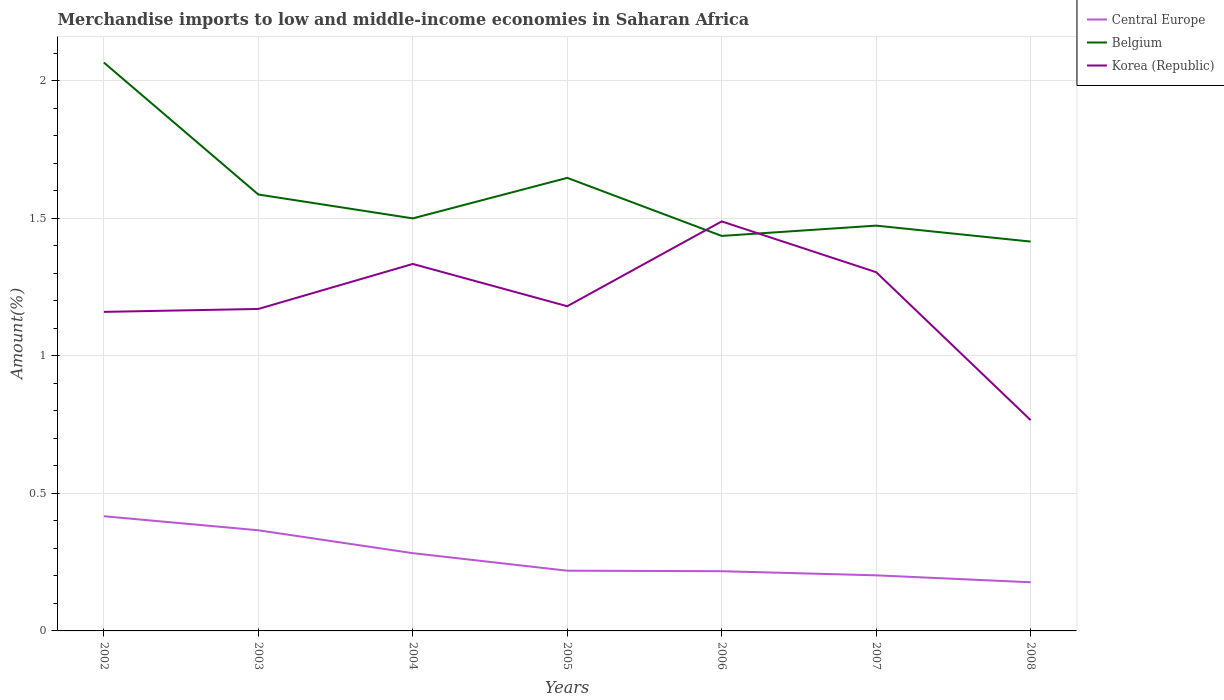How many different coloured lines are there?
Make the answer very short. 3. Does the line corresponding to Central Europe intersect with the line corresponding to Korea (Republic)?
Provide a succinct answer. No. Is the number of lines equal to the number of legend labels?
Give a very brief answer. Yes. Across all years, what is the maximum percentage of amount earned from merchandise imports in Central Europe?
Provide a succinct answer. 0.18. What is the total percentage of amount earned from merchandise imports in Korea (Republic) in the graph?
Provide a succinct answer. -0.17. What is the difference between the highest and the second highest percentage of amount earned from merchandise imports in Belgium?
Provide a short and direct response. 0.65. What is the difference between the highest and the lowest percentage of amount earned from merchandise imports in Central Europe?
Offer a very short reply. 3. Is the percentage of amount earned from merchandise imports in Central Europe strictly greater than the percentage of amount earned from merchandise imports in Belgium over the years?
Your response must be concise. Yes. How many years are there in the graph?
Offer a terse response. 7. What is the difference between two consecutive major ticks on the Y-axis?
Keep it short and to the point. 0.5. Where does the legend appear in the graph?
Provide a succinct answer. Top right. How many legend labels are there?
Your response must be concise. 3. How are the legend labels stacked?
Your response must be concise. Vertical. What is the title of the graph?
Your response must be concise. Merchandise imports to low and middle-income economies in Saharan Africa. Does "Middle income" appear as one of the legend labels in the graph?
Keep it short and to the point. No. What is the label or title of the X-axis?
Your answer should be compact. Years. What is the label or title of the Y-axis?
Give a very brief answer. Amount(%). What is the Amount(%) of Central Europe in 2002?
Your answer should be very brief. 0.42. What is the Amount(%) of Belgium in 2002?
Make the answer very short. 2.07. What is the Amount(%) in Korea (Republic) in 2002?
Offer a very short reply. 1.16. What is the Amount(%) of Central Europe in 2003?
Your answer should be compact. 0.37. What is the Amount(%) of Belgium in 2003?
Offer a terse response. 1.59. What is the Amount(%) of Korea (Republic) in 2003?
Provide a succinct answer. 1.17. What is the Amount(%) in Central Europe in 2004?
Offer a terse response. 0.28. What is the Amount(%) in Belgium in 2004?
Keep it short and to the point. 1.5. What is the Amount(%) in Korea (Republic) in 2004?
Your response must be concise. 1.33. What is the Amount(%) in Central Europe in 2005?
Your answer should be compact. 0.22. What is the Amount(%) of Belgium in 2005?
Provide a succinct answer. 1.65. What is the Amount(%) of Korea (Republic) in 2005?
Offer a very short reply. 1.18. What is the Amount(%) of Central Europe in 2006?
Offer a terse response. 0.22. What is the Amount(%) of Belgium in 2006?
Give a very brief answer. 1.44. What is the Amount(%) in Korea (Republic) in 2006?
Your response must be concise. 1.49. What is the Amount(%) in Central Europe in 2007?
Make the answer very short. 0.2. What is the Amount(%) of Belgium in 2007?
Offer a very short reply. 1.47. What is the Amount(%) of Korea (Republic) in 2007?
Give a very brief answer. 1.3. What is the Amount(%) of Central Europe in 2008?
Provide a short and direct response. 0.18. What is the Amount(%) in Belgium in 2008?
Your answer should be compact. 1.42. What is the Amount(%) in Korea (Republic) in 2008?
Offer a very short reply. 0.77. Across all years, what is the maximum Amount(%) in Central Europe?
Offer a very short reply. 0.42. Across all years, what is the maximum Amount(%) in Belgium?
Ensure brevity in your answer.  2.07. Across all years, what is the maximum Amount(%) in Korea (Republic)?
Give a very brief answer. 1.49. Across all years, what is the minimum Amount(%) of Central Europe?
Provide a short and direct response. 0.18. Across all years, what is the minimum Amount(%) of Belgium?
Your answer should be compact. 1.42. Across all years, what is the minimum Amount(%) of Korea (Republic)?
Your response must be concise. 0.77. What is the total Amount(%) in Central Europe in the graph?
Your answer should be compact. 1.88. What is the total Amount(%) of Belgium in the graph?
Your answer should be very brief. 11.13. What is the total Amount(%) in Korea (Republic) in the graph?
Offer a very short reply. 8.41. What is the difference between the Amount(%) of Central Europe in 2002 and that in 2003?
Offer a terse response. 0.05. What is the difference between the Amount(%) of Belgium in 2002 and that in 2003?
Provide a short and direct response. 0.48. What is the difference between the Amount(%) of Korea (Republic) in 2002 and that in 2003?
Provide a short and direct response. -0.01. What is the difference between the Amount(%) of Central Europe in 2002 and that in 2004?
Make the answer very short. 0.13. What is the difference between the Amount(%) of Belgium in 2002 and that in 2004?
Keep it short and to the point. 0.57. What is the difference between the Amount(%) in Korea (Republic) in 2002 and that in 2004?
Your answer should be very brief. -0.17. What is the difference between the Amount(%) of Central Europe in 2002 and that in 2005?
Ensure brevity in your answer.  0.2. What is the difference between the Amount(%) of Belgium in 2002 and that in 2005?
Your response must be concise. 0.42. What is the difference between the Amount(%) of Korea (Republic) in 2002 and that in 2005?
Keep it short and to the point. -0.02. What is the difference between the Amount(%) in Central Europe in 2002 and that in 2006?
Offer a very short reply. 0.2. What is the difference between the Amount(%) of Belgium in 2002 and that in 2006?
Your response must be concise. 0.63. What is the difference between the Amount(%) in Korea (Republic) in 2002 and that in 2006?
Your response must be concise. -0.33. What is the difference between the Amount(%) of Central Europe in 2002 and that in 2007?
Make the answer very short. 0.21. What is the difference between the Amount(%) of Belgium in 2002 and that in 2007?
Your answer should be compact. 0.59. What is the difference between the Amount(%) in Korea (Republic) in 2002 and that in 2007?
Give a very brief answer. -0.14. What is the difference between the Amount(%) in Central Europe in 2002 and that in 2008?
Offer a very short reply. 0.24. What is the difference between the Amount(%) in Belgium in 2002 and that in 2008?
Make the answer very short. 0.65. What is the difference between the Amount(%) in Korea (Republic) in 2002 and that in 2008?
Give a very brief answer. 0.39. What is the difference between the Amount(%) of Central Europe in 2003 and that in 2004?
Provide a short and direct response. 0.08. What is the difference between the Amount(%) of Belgium in 2003 and that in 2004?
Ensure brevity in your answer.  0.09. What is the difference between the Amount(%) in Korea (Republic) in 2003 and that in 2004?
Keep it short and to the point. -0.16. What is the difference between the Amount(%) of Central Europe in 2003 and that in 2005?
Give a very brief answer. 0.15. What is the difference between the Amount(%) of Belgium in 2003 and that in 2005?
Offer a very short reply. -0.06. What is the difference between the Amount(%) in Korea (Republic) in 2003 and that in 2005?
Provide a succinct answer. -0.01. What is the difference between the Amount(%) of Central Europe in 2003 and that in 2006?
Provide a short and direct response. 0.15. What is the difference between the Amount(%) of Belgium in 2003 and that in 2006?
Provide a succinct answer. 0.15. What is the difference between the Amount(%) of Korea (Republic) in 2003 and that in 2006?
Make the answer very short. -0.32. What is the difference between the Amount(%) of Central Europe in 2003 and that in 2007?
Provide a short and direct response. 0.16. What is the difference between the Amount(%) in Belgium in 2003 and that in 2007?
Your answer should be compact. 0.11. What is the difference between the Amount(%) of Korea (Republic) in 2003 and that in 2007?
Your response must be concise. -0.13. What is the difference between the Amount(%) in Central Europe in 2003 and that in 2008?
Your response must be concise. 0.19. What is the difference between the Amount(%) of Belgium in 2003 and that in 2008?
Provide a succinct answer. 0.17. What is the difference between the Amount(%) in Korea (Republic) in 2003 and that in 2008?
Your answer should be compact. 0.4. What is the difference between the Amount(%) in Central Europe in 2004 and that in 2005?
Give a very brief answer. 0.06. What is the difference between the Amount(%) in Belgium in 2004 and that in 2005?
Offer a terse response. -0.15. What is the difference between the Amount(%) of Korea (Republic) in 2004 and that in 2005?
Make the answer very short. 0.15. What is the difference between the Amount(%) of Central Europe in 2004 and that in 2006?
Your answer should be compact. 0.07. What is the difference between the Amount(%) in Belgium in 2004 and that in 2006?
Keep it short and to the point. 0.06. What is the difference between the Amount(%) in Korea (Republic) in 2004 and that in 2006?
Your answer should be very brief. -0.15. What is the difference between the Amount(%) in Central Europe in 2004 and that in 2007?
Make the answer very short. 0.08. What is the difference between the Amount(%) in Belgium in 2004 and that in 2007?
Your answer should be compact. 0.03. What is the difference between the Amount(%) in Korea (Republic) in 2004 and that in 2007?
Your answer should be very brief. 0.03. What is the difference between the Amount(%) of Central Europe in 2004 and that in 2008?
Give a very brief answer. 0.11. What is the difference between the Amount(%) of Belgium in 2004 and that in 2008?
Ensure brevity in your answer.  0.08. What is the difference between the Amount(%) in Korea (Republic) in 2004 and that in 2008?
Give a very brief answer. 0.57. What is the difference between the Amount(%) of Central Europe in 2005 and that in 2006?
Make the answer very short. 0. What is the difference between the Amount(%) of Belgium in 2005 and that in 2006?
Make the answer very short. 0.21. What is the difference between the Amount(%) of Korea (Republic) in 2005 and that in 2006?
Provide a succinct answer. -0.31. What is the difference between the Amount(%) in Central Europe in 2005 and that in 2007?
Give a very brief answer. 0.02. What is the difference between the Amount(%) in Belgium in 2005 and that in 2007?
Make the answer very short. 0.17. What is the difference between the Amount(%) of Korea (Republic) in 2005 and that in 2007?
Offer a terse response. -0.12. What is the difference between the Amount(%) in Central Europe in 2005 and that in 2008?
Your response must be concise. 0.04. What is the difference between the Amount(%) of Belgium in 2005 and that in 2008?
Make the answer very short. 0.23. What is the difference between the Amount(%) in Korea (Republic) in 2005 and that in 2008?
Ensure brevity in your answer.  0.41. What is the difference between the Amount(%) in Central Europe in 2006 and that in 2007?
Offer a terse response. 0.01. What is the difference between the Amount(%) in Belgium in 2006 and that in 2007?
Ensure brevity in your answer.  -0.04. What is the difference between the Amount(%) of Korea (Republic) in 2006 and that in 2007?
Keep it short and to the point. 0.18. What is the difference between the Amount(%) of Central Europe in 2006 and that in 2008?
Offer a terse response. 0.04. What is the difference between the Amount(%) of Belgium in 2006 and that in 2008?
Provide a short and direct response. 0.02. What is the difference between the Amount(%) in Korea (Republic) in 2006 and that in 2008?
Offer a terse response. 0.72. What is the difference between the Amount(%) in Central Europe in 2007 and that in 2008?
Your answer should be compact. 0.03. What is the difference between the Amount(%) in Belgium in 2007 and that in 2008?
Give a very brief answer. 0.06. What is the difference between the Amount(%) in Korea (Republic) in 2007 and that in 2008?
Provide a short and direct response. 0.54. What is the difference between the Amount(%) of Central Europe in 2002 and the Amount(%) of Belgium in 2003?
Offer a very short reply. -1.17. What is the difference between the Amount(%) of Central Europe in 2002 and the Amount(%) of Korea (Republic) in 2003?
Your answer should be very brief. -0.75. What is the difference between the Amount(%) in Belgium in 2002 and the Amount(%) in Korea (Republic) in 2003?
Provide a short and direct response. 0.9. What is the difference between the Amount(%) of Central Europe in 2002 and the Amount(%) of Belgium in 2004?
Offer a very short reply. -1.08. What is the difference between the Amount(%) in Central Europe in 2002 and the Amount(%) in Korea (Republic) in 2004?
Your answer should be very brief. -0.92. What is the difference between the Amount(%) in Belgium in 2002 and the Amount(%) in Korea (Republic) in 2004?
Provide a succinct answer. 0.73. What is the difference between the Amount(%) in Central Europe in 2002 and the Amount(%) in Belgium in 2005?
Keep it short and to the point. -1.23. What is the difference between the Amount(%) in Central Europe in 2002 and the Amount(%) in Korea (Republic) in 2005?
Ensure brevity in your answer.  -0.76. What is the difference between the Amount(%) in Belgium in 2002 and the Amount(%) in Korea (Republic) in 2005?
Offer a very short reply. 0.89. What is the difference between the Amount(%) in Central Europe in 2002 and the Amount(%) in Belgium in 2006?
Ensure brevity in your answer.  -1.02. What is the difference between the Amount(%) in Central Europe in 2002 and the Amount(%) in Korea (Republic) in 2006?
Provide a succinct answer. -1.07. What is the difference between the Amount(%) in Belgium in 2002 and the Amount(%) in Korea (Republic) in 2006?
Your answer should be compact. 0.58. What is the difference between the Amount(%) of Central Europe in 2002 and the Amount(%) of Belgium in 2007?
Your answer should be very brief. -1.06. What is the difference between the Amount(%) in Central Europe in 2002 and the Amount(%) in Korea (Republic) in 2007?
Give a very brief answer. -0.89. What is the difference between the Amount(%) in Belgium in 2002 and the Amount(%) in Korea (Republic) in 2007?
Give a very brief answer. 0.76. What is the difference between the Amount(%) of Central Europe in 2002 and the Amount(%) of Belgium in 2008?
Give a very brief answer. -1. What is the difference between the Amount(%) of Central Europe in 2002 and the Amount(%) of Korea (Republic) in 2008?
Ensure brevity in your answer.  -0.35. What is the difference between the Amount(%) in Belgium in 2002 and the Amount(%) in Korea (Republic) in 2008?
Your answer should be very brief. 1.3. What is the difference between the Amount(%) of Central Europe in 2003 and the Amount(%) of Belgium in 2004?
Provide a short and direct response. -1.13. What is the difference between the Amount(%) of Central Europe in 2003 and the Amount(%) of Korea (Republic) in 2004?
Provide a succinct answer. -0.97. What is the difference between the Amount(%) in Belgium in 2003 and the Amount(%) in Korea (Republic) in 2004?
Keep it short and to the point. 0.25. What is the difference between the Amount(%) of Central Europe in 2003 and the Amount(%) of Belgium in 2005?
Make the answer very short. -1.28. What is the difference between the Amount(%) in Central Europe in 2003 and the Amount(%) in Korea (Republic) in 2005?
Offer a very short reply. -0.81. What is the difference between the Amount(%) of Belgium in 2003 and the Amount(%) of Korea (Republic) in 2005?
Provide a short and direct response. 0.41. What is the difference between the Amount(%) in Central Europe in 2003 and the Amount(%) in Belgium in 2006?
Offer a very short reply. -1.07. What is the difference between the Amount(%) of Central Europe in 2003 and the Amount(%) of Korea (Republic) in 2006?
Offer a very short reply. -1.12. What is the difference between the Amount(%) in Belgium in 2003 and the Amount(%) in Korea (Republic) in 2006?
Keep it short and to the point. 0.1. What is the difference between the Amount(%) of Central Europe in 2003 and the Amount(%) of Belgium in 2007?
Offer a very short reply. -1.11. What is the difference between the Amount(%) in Central Europe in 2003 and the Amount(%) in Korea (Republic) in 2007?
Your answer should be very brief. -0.94. What is the difference between the Amount(%) in Belgium in 2003 and the Amount(%) in Korea (Republic) in 2007?
Your answer should be compact. 0.28. What is the difference between the Amount(%) of Central Europe in 2003 and the Amount(%) of Belgium in 2008?
Your response must be concise. -1.05. What is the difference between the Amount(%) in Central Europe in 2003 and the Amount(%) in Korea (Republic) in 2008?
Ensure brevity in your answer.  -0.4. What is the difference between the Amount(%) of Belgium in 2003 and the Amount(%) of Korea (Republic) in 2008?
Provide a succinct answer. 0.82. What is the difference between the Amount(%) of Central Europe in 2004 and the Amount(%) of Belgium in 2005?
Your answer should be very brief. -1.36. What is the difference between the Amount(%) in Central Europe in 2004 and the Amount(%) in Korea (Republic) in 2005?
Offer a very short reply. -0.9. What is the difference between the Amount(%) in Belgium in 2004 and the Amount(%) in Korea (Republic) in 2005?
Make the answer very short. 0.32. What is the difference between the Amount(%) in Central Europe in 2004 and the Amount(%) in Belgium in 2006?
Ensure brevity in your answer.  -1.15. What is the difference between the Amount(%) in Central Europe in 2004 and the Amount(%) in Korea (Republic) in 2006?
Offer a terse response. -1.21. What is the difference between the Amount(%) of Belgium in 2004 and the Amount(%) of Korea (Republic) in 2006?
Provide a succinct answer. 0.01. What is the difference between the Amount(%) of Central Europe in 2004 and the Amount(%) of Belgium in 2007?
Ensure brevity in your answer.  -1.19. What is the difference between the Amount(%) in Central Europe in 2004 and the Amount(%) in Korea (Republic) in 2007?
Your response must be concise. -1.02. What is the difference between the Amount(%) in Belgium in 2004 and the Amount(%) in Korea (Republic) in 2007?
Provide a succinct answer. 0.2. What is the difference between the Amount(%) in Central Europe in 2004 and the Amount(%) in Belgium in 2008?
Your answer should be very brief. -1.13. What is the difference between the Amount(%) of Central Europe in 2004 and the Amount(%) of Korea (Republic) in 2008?
Make the answer very short. -0.48. What is the difference between the Amount(%) of Belgium in 2004 and the Amount(%) of Korea (Republic) in 2008?
Provide a succinct answer. 0.73. What is the difference between the Amount(%) in Central Europe in 2005 and the Amount(%) in Belgium in 2006?
Offer a very short reply. -1.22. What is the difference between the Amount(%) of Central Europe in 2005 and the Amount(%) of Korea (Republic) in 2006?
Your response must be concise. -1.27. What is the difference between the Amount(%) of Belgium in 2005 and the Amount(%) of Korea (Republic) in 2006?
Ensure brevity in your answer.  0.16. What is the difference between the Amount(%) in Central Europe in 2005 and the Amount(%) in Belgium in 2007?
Ensure brevity in your answer.  -1.25. What is the difference between the Amount(%) of Central Europe in 2005 and the Amount(%) of Korea (Republic) in 2007?
Make the answer very short. -1.09. What is the difference between the Amount(%) in Belgium in 2005 and the Amount(%) in Korea (Republic) in 2007?
Provide a short and direct response. 0.34. What is the difference between the Amount(%) of Central Europe in 2005 and the Amount(%) of Belgium in 2008?
Your answer should be compact. -1.2. What is the difference between the Amount(%) of Central Europe in 2005 and the Amount(%) of Korea (Republic) in 2008?
Ensure brevity in your answer.  -0.55. What is the difference between the Amount(%) of Belgium in 2005 and the Amount(%) of Korea (Republic) in 2008?
Your answer should be very brief. 0.88. What is the difference between the Amount(%) in Central Europe in 2006 and the Amount(%) in Belgium in 2007?
Your response must be concise. -1.26. What is the difference between the Amount(%) of Central Europe in 2006 and the Amount(%) of Korea (Republic) in 2007?
Ensure brevity in your answer.  -1.09. What is the difference between the Amount(%) of Belgium in 2006 and the Amount(%) of Korea (Republic) in 2007?
Your response must be concise. 0.13. What is the difference between the Amount(%) in Central Europe in 2006 and the Amount(%) in Belgium in 2008?
Provide a succinct answer. -1.2. What is the difference between the Amount(%) of Central Europe in 2006 and the Amount(%) of Korea (Republic) in 2008?
Provide a short and direct response. -0.55. What is the difference between the Amount(%) in Belgium in 2006 and the Amount(%) in Korea (Republic) in 2008?
Offer a very short reply. 0.67. What is the difference between the Amount(%) of Central Europe in 2007 and the Amount(%) of Belgium in 2008?
Keep it short and to the point. -1.21. What is the difference between the Amount(%) of Central Europe in 2007 and the Amount(%) of Korea (Republic) in 2008?
Your answer should be compact. -0.56. What is the difference between the Amount(%) in Belgium in 2007 and the Amount(%) in Korea (Republic) in 2008?
Provide a short and direct response. 0.71. What is the average Amount(%) of Central Europe per year?
Your answer should be compact. 0.27. What is the average Amount(%) in Belgium per year?
Your response must be concise. 1.59. What is the average Amount(%) in Korea (Republic) per year?
Provide a short and direct response. 1.2. In the year 2002, what is the difference between the Amount(%) in Central Europe and Amount(%) in Belgium?
Provide a succinct answer. -1.65. In the year 2002, what is the difference between the Amount(%) in Central Europe and Amount(%) in Korea (Republic)?
Ensure brevity in your answer.  -0.74. In the year 2002, what is the difference between the Amount(%) in Belgium and Amount(%) in Korea (Republic)?
Your answer should be very brief. 0.91. In the year 2003, what is the difference between the Amount(%) of Central Europe and Amount(%) of Belgium?
Your answer should be very brief. -1.22. In the year 2003, what is the difference between the Amount(%) in Central Europe and Amount(%) in Korea (Republic)?
Offer a very short reply. -0.8. In the year 2003, what is the difference between the Amount(%) in Belgium and Amount(%) in Korea (Republic)?
Keep it short and to the point. 0.42. In the year 2004, what is the difference between the Amount(%) in Central Europe and Amount(%) in Belgium?
Provide a succinct answer. -1.22. In the year 2004, what is the difference between the Amount(%) of Central Europe and Amount(%) of Korea (Republic)?
Make the answer very short. -1.05. In the year 2004, what is the difference between the Amount(%) of Belgium and Amount(%) of Korea (Republic)?
Your answer should be compact. 0.17. In the year 2005, what is the difference between the Amount(%) of Central Europe and Amount(%) of Belgium?
Your response must be concise. -1.43. In the year 2005, what is the difference between the Amount(%) in Central Europe and Amount(%) in Korea (Republic)?
Offer a terse response. -0.96. In the year 2005, what is the difference between the Amount(%) of Belgium and Amount(%) of Korea (Republic)?
Your answer should be compact. 0.47. In the year 2006, what is the difference between the Amount(%) in Central Europe and Amount(%) in Belgium?
Give a very brief answer. -1.22. In the year 2006, what is the difference between the Amount(%) of Central Europe and Amount(%) of Korea (Republic)?
Provide a short and direct response. -1.27. In the year 2006, what is the difference between the Amount(%) in Belgium and Amount(%) in Korea (Republic)?
Make the answer very short. -0.05. In the year 2007, what is the difference between the Amount(%) of Central Europe and Amount(%) of Belgium?
Your response must be concise. -1.27. In the year 2007, what is the difference between the Amount(%) of Central Europe and Amount(%) of Korea (Republic)?
Your answer should be very brief. -1.1. In the year 2007, what is the difference between the Amount(%) of Belgium and Amount(%) of Korea (Republic)?
Provide a succinct answer. 0.17. In the year 2008, what is the difference between the Amount(%) of Central Europe and Amount(%) of Belgium?
Offer a terse response. -1.24. In the year 2008, what is the difference between the Amount(%) in Central Europe and Amount(%) in Korea (Republic)?
Provide a succinct answer. -0.59. In the year 2008, what is the difference between the Amount(%) in Belgium and Amount(%) in Korea (Republic)?
Make the answer very short. 0.65. What is the ratio of the Amount(%) in Central Europe in 2002 to that in 2003?
Your response must be concise. 1.14. What is the ratio of the Amount(%) in Belgium in 2002 to that in 2003?
Ensure brevity in your answer.  1.3. What is the ratio of the Amount(%) in Korea (Republic) in 2002 to that in 2003?
Ensure brevity in your answer.  0.99. What is the ratio of the Amount(%) of Central Europe in 2002 to that in 2004?
Keep it short and to the point. 1.48. What is the ratio of the Amount(%) in Belgium in 2002 to that in 2004?
Offer a terse response. 1.38. What is the ratio of the Amount(%) in Korea (Republic) in 2002 to that in 2004?
Ensure brevity in your answer.  0.87. What is the ratio of the Amount(%) of Central Europe in 2002 to that in 2005?
Give a very brief answer. 1.9. What is the ratio of the Amount(%) of Belgium in 2002 to that in 2005?
Provide a succinct answer. 1.25. What is the ratio of the Amount(%) of Korea (Republic) in 2002 to that in 2005?
Give a very brief answer. 0.98. What is the ratio of the Amount(%) in Central Europe in 2002 to that in 2006?
Offer a terse response. 1.92. What is the ratio of the Amount(%) of Belgium in 2002 to that in 2006?
Provide a short and direct response. 1.44. What is the ratio of the Amount(%) in Korea (Republic) in 2002 to that in 2006?
Keep it short and to the point. 0.78. What is the ratio of the Amount(%) in Central Europe in 2002 to that in 2007?
Offer a terse response. 2.06. What is the ratio of the Amount(%) of Belgium in 2002 to that in 2007?
Provide a short and direct response. 1.4. What is the ratio of the Amount(%) of Korea (Republic) in 2002 to that in 2007?
Your response must be concise. 0.89. What is the ratio of the Amount(%) of Central Europe in 2002 to that in 2008?
Your answer should be compact. 2.36. What is the ratio of the Amount(%) of Belgium in 2002 to that in 2008?
Give a very brief answer. 1.46. What is the ratio of the Amount(%) of Korea (Republic) in 2002 to that in 2008?
Offer a very short reply. 1.51. What is the ratio of the Amount(%) in Central Europe in 2003 to that in 2004?
Offer a very short reply. 1.29. What is the ratio of the Amount(%) in Belgium in 2003 to that in 2004?
Ensure brevity in your answer.  1.06. What is the ratio of the Amount(%) in Korea (Republic) in 2003 to that in 2004?
Make the answer very short. 0.88. What is the ratio of the Amount(%) of Central Europe in 2003 to that in 2005?
Keep it short and to the point. 1.67. What is the ratio of the Amount(%) of Belgium in 2003 to that in 2005?
Your answer should be compact. 0.96. What is the ratio of the Amount(%) of Central Europe in 2003 to that in 2006?
Your response must be concise. 1.69. What is the ratio of the Amount(%) in Belgium in 2003 to that in 2006?
Your response must be concise. 1.1. What is the ratio of the Amount(%) of Korea (Republic) in 2003 to that in 2006?
Give a very brief answer. 0.79. What is the ratio of the Amount(%) in Central Europe in 2003 to that in 2007?
Offer a very short reply. 1.81. What is the ratio of the Amount(%) in Belgium in 2003 to that in 2007?
Offer a terse response. 1.08. What is the ratio of the Amount(%) of Korea (Republic) in 2003 to that in 2007?
Your response must be concise. 0.9. What is the ratio of the Amount(%) in Central Europe in 2003 to that in 2008?
Keep it short and to the point. 2.07. What is the ratio of the Amount(%) of Belgium in 2003 to that in 2008?
Keep it short and to the point. 1.12. What is the ratio of the Amount(%) in Korea (Republic) in 2003 to that in 2008?
Make the answer very short. 1.53. What is the ratio of the Amount(%) in Central Europe in 2004 to that in 2005?
Provide a succinct answer. 1.29. What is the ratio of the Amount(%) in Belgium in 2004 to that in 2005?
Your answer should be very brief. 0.91. What is the ratio of the Amount(%) of Korea (Republic) in 2004 to that in 2005?
Ensure brevity in your answer.  1.13. What is the ratio of the Amount(%) of Central Europe in 2004 to that in 2006?
Give a very brief answer. 1.3. What is the ratio of the Amount(%) in Belgium in 2004 to that in 2006?
Ensure brevity in your answer.  1.04. What is the ratio of the Amount(%) in Korea (Republic) in 2004 to that in 2006?
Your response must be concise. 0.9. What is the ratio of the Amount(%) of Central Europe in 2004 to that in 2007?
Offer a terse response. 1.4. What is the ratio of the Amount(%) in Belgium in 2004 to that in 2007?
Offer a terse response. 1.02. What is the ratio of the Amount(%) in Korea (Republic) in 2004 to that in 2007?
Provide a succinct answer. 1.02. What is the ratio of the Amount(%) of Central Europe in 2004 to that in 2008?
Give a very brief answer. 1.6. What is the ratio of the Amount(%) of Belgium in 2004 to that in 2008?
Your answer should be very brief. 1.06. What is the ratio of the Amount(%) of Korea (Republic) in 2004 to that in 2008?
Provide a short and direct response. 1.74. What is the ratio of the Amount(%) of Central Europe in 2005 to that in 2006?
Your answer should be compact. 1.01. What is the ratio of the Amount(%) of Belgium in 2005 to that in 2006?
Keep it short and to the point. 1.15. What is the ratio of the Amount(%) of Korea (Republic) in 2005 to that in 2006?
Offer a very short reply. 0.79. What is the ratio of the Amount(%) in Central Europe in 2005 to that in 2007?
Give a very brief answer. 1.08. What is the ratio of the Amount(%) of Belgium in 2005 to that in 2007?
Your answer should be very brief. 1.12. What is the ratio of the Amount(%) in Korea (Republic) in 2005 to that in 2007?
Your answer should be compact. 0.91. What is the ratio of the Amount(%) of Central Europe in 2005 to that in 2008?
Keep it short and to the point. 1.24. What is the ratio of the Amount(%) in Belgium in 2005 to that in 2008?
Ensure brevity in your answer.  1.16. What is the ratio of the Amount(%) of Korea (Republic) in 2005 to that in 2008?
Provide a short and direct response. 1.54. What is the ratio of the Amount(%) of Central Europe in 2006 to that in 2007?
Ensure brevity in your answer.  1.07. What is the ratio of the Amount(%) in Belgium in 2006 to that in 2007?
Provide a short and direct response. 0.97. What is the ratio of the Amount(%) of Korea (Republic) in 2006 to that in 2007?
Keep it short and to the point. 1.14. What is the ratio of the Amount(%) of Central Europe in 2006 to that in 2008?
Your answer should be very brief. 1.23. What is the ratio of the Amount(%) of Belgium in 2006 to that in 2008?
Give a very brief answer. 1.01. What is the ratio of the Amount(%) of Korea (Republic) in 2006 to that in 2008?
Keep it short and to the point. 1.94. What is the ratio of the Amount(%) of Central Europe in 2007 to that in 2008?
Your answer should be compact. 1.14. What is the ratio of the Amount(%) in Belgium in 2007 to that in 2008?
Offer a terse response. 1.04. What is the ratio of the Amount(%) of Korea (Republic) in 2007 to that in 2008?
Provide a short and direct response. 1.7. What is the difference between the highest and the second highest Amount(%) of Central Europe?
Your answer should be very brief. 0.05. What is the difference between the highest and the second highest Amount(%) of Belgium?
Make the answer very short. 0.42. What is the difference between the highest and the second highest Amount(%) in Korea (Republic)?
Provide a succinct answer. 0.15. What is the difference between the highest and the lowest Amount(%) in Central Europe?
Offer a very short reply. 0.24. What is the difference between the highest and the lowest Amount(%) in Belgium?
Your response must be concise. 0.65. What is the difference between the highest and the lowest Amount(%) in Korea (Republic)?
Give a very brief answer. 0.72. 